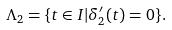<formula> <loc_0><loc_0><loc_500><loc_500>\Lambda _ { 2 } = \{ t \in I | \delta _ { 2 } ^ { \prime } ( t ) = 0 \} .</formula> 